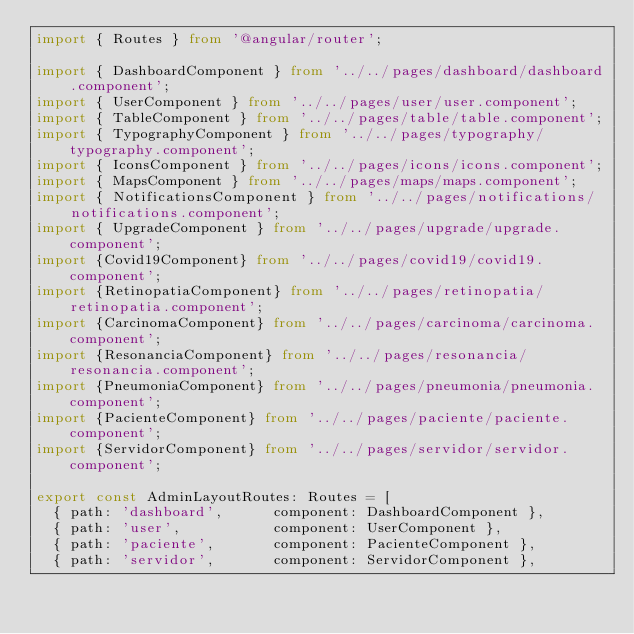<code> <loc_0><loc_0><loc_500><loc_500><_TypeScript_>import { Routes } from '@angular/router';

import { DashboardComponent } from '../../pages/dashboard/dashboard.component';
import { UserComponent } from '../../pages/user/user.component';
import { TableComponent } from '../../pages/table/table.component';
import { TypographyComponent } from '../../pages/typography/typography.component';
import { IconsComponent } from '../../pages/icons/icons.component';
import { MapsComponent } from '../../pages/maps/maps.component';
import { NotificationsComponent } from '../../pages/notifications/notifications.component';
import { UpgradeComponent } from '../../pages/upgrade/upgrade.component';
import {Covid19Component} from '../../pages/covid19/covid19.component';
import {RetinopatiaComponent} from '../../pages/retinopatia/retinopatia.component';
import {CarcinomaComponent} from '../../pages/carcinoma/carcinoma.component';
import {ResonanciaComponent} from '../../pages/resonancia/resonancia.component';
import {PneumoniaComponent} from '../../pages/pneumonia/pneumonia.component';
import {PacienteComponent} from '../../pages/paciente/paciente.component';
import {ServidorComponent} from '../../pages/servidor/servidor.component';

export const AdminLayoutRoutes: Routes = [
  { path: 'dashboard',      component: DashboardComponent },
  { path: 'user',           component: UserComponent },
  { path: 'paciente',       component: PacienteComponent },
  { path: 'servidor',       component: ServidorComponent },</code> 